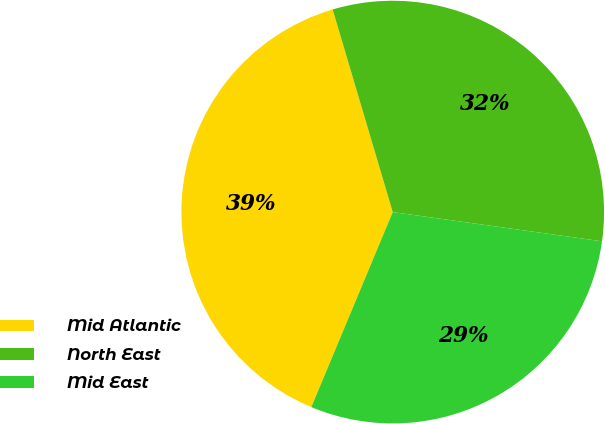Convert chart. <chart><loc_0><loc_0><loc_500><loc_500><pie_chart><fcel>Mid Atlantic<fcel>North East<fcel>Mid East<nl><fcel>39.12%<fcel>31.8%<fcel>29.09%<nl></chart> 